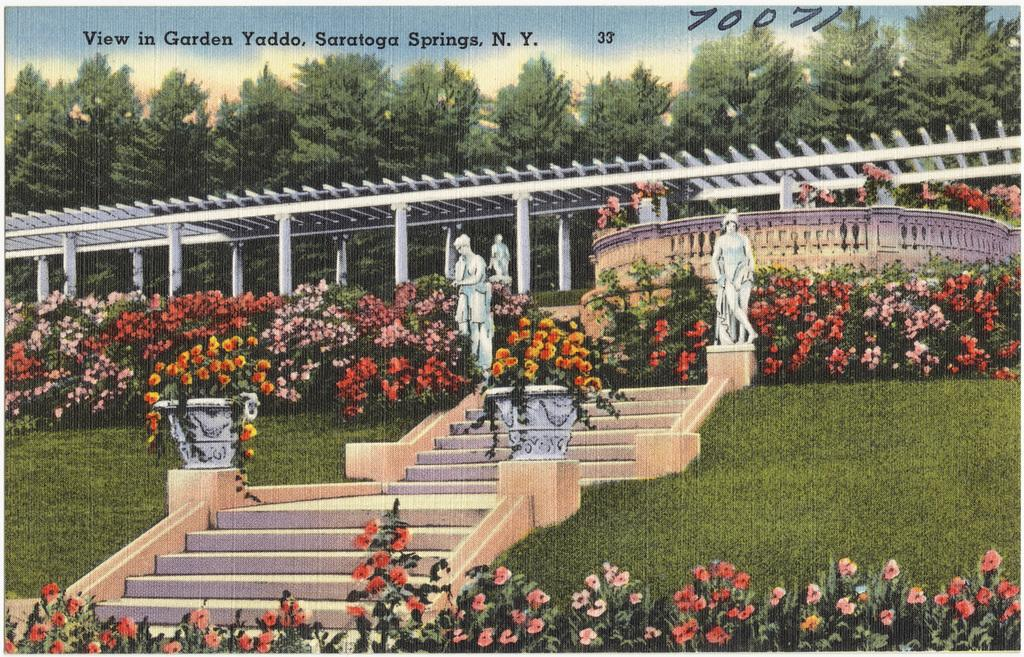<image>
Create a compact narrative representing the image presented. An outdoor area with lots of flowers is labeled as Saratoga Springs. 